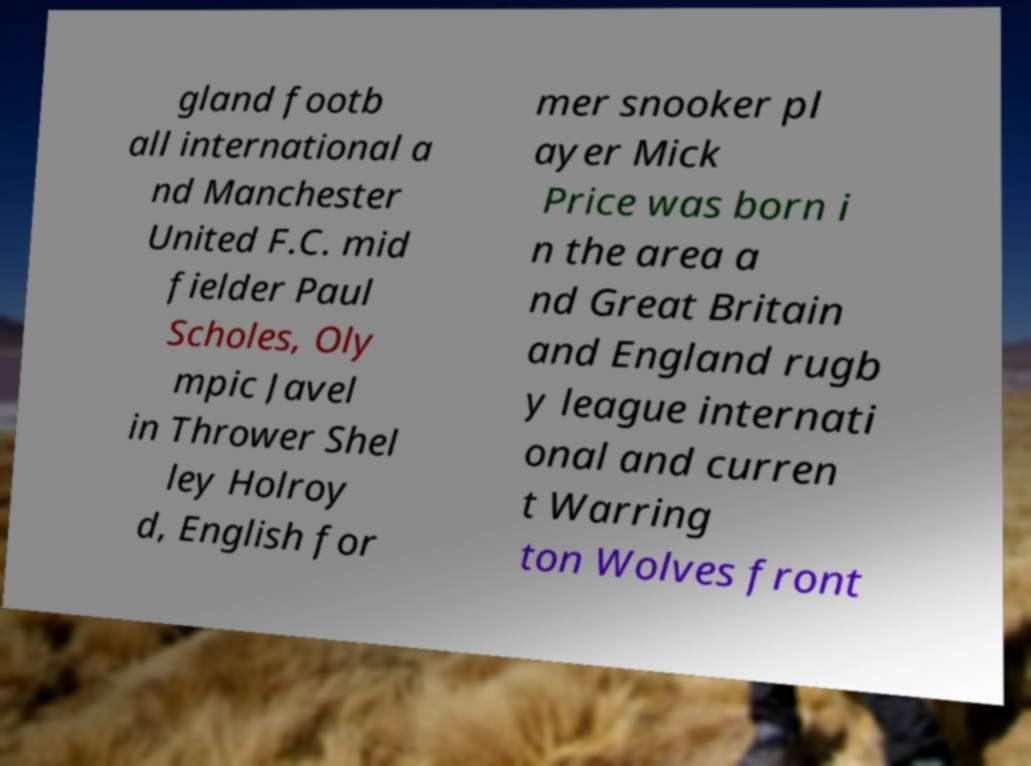Could you assist in decoding the text presented in this image and type it out clearly? gland footb all international a nd Manchester United F.C. mid fielder Paul Scholes, Oly mpic Javel in Thrower Shel ley Holroy d, English for mer snooker pl ayer Mick Price was born i n the area a nd Great Britain and England rugb y league internati onal and curren t Warring ton Wolves front 